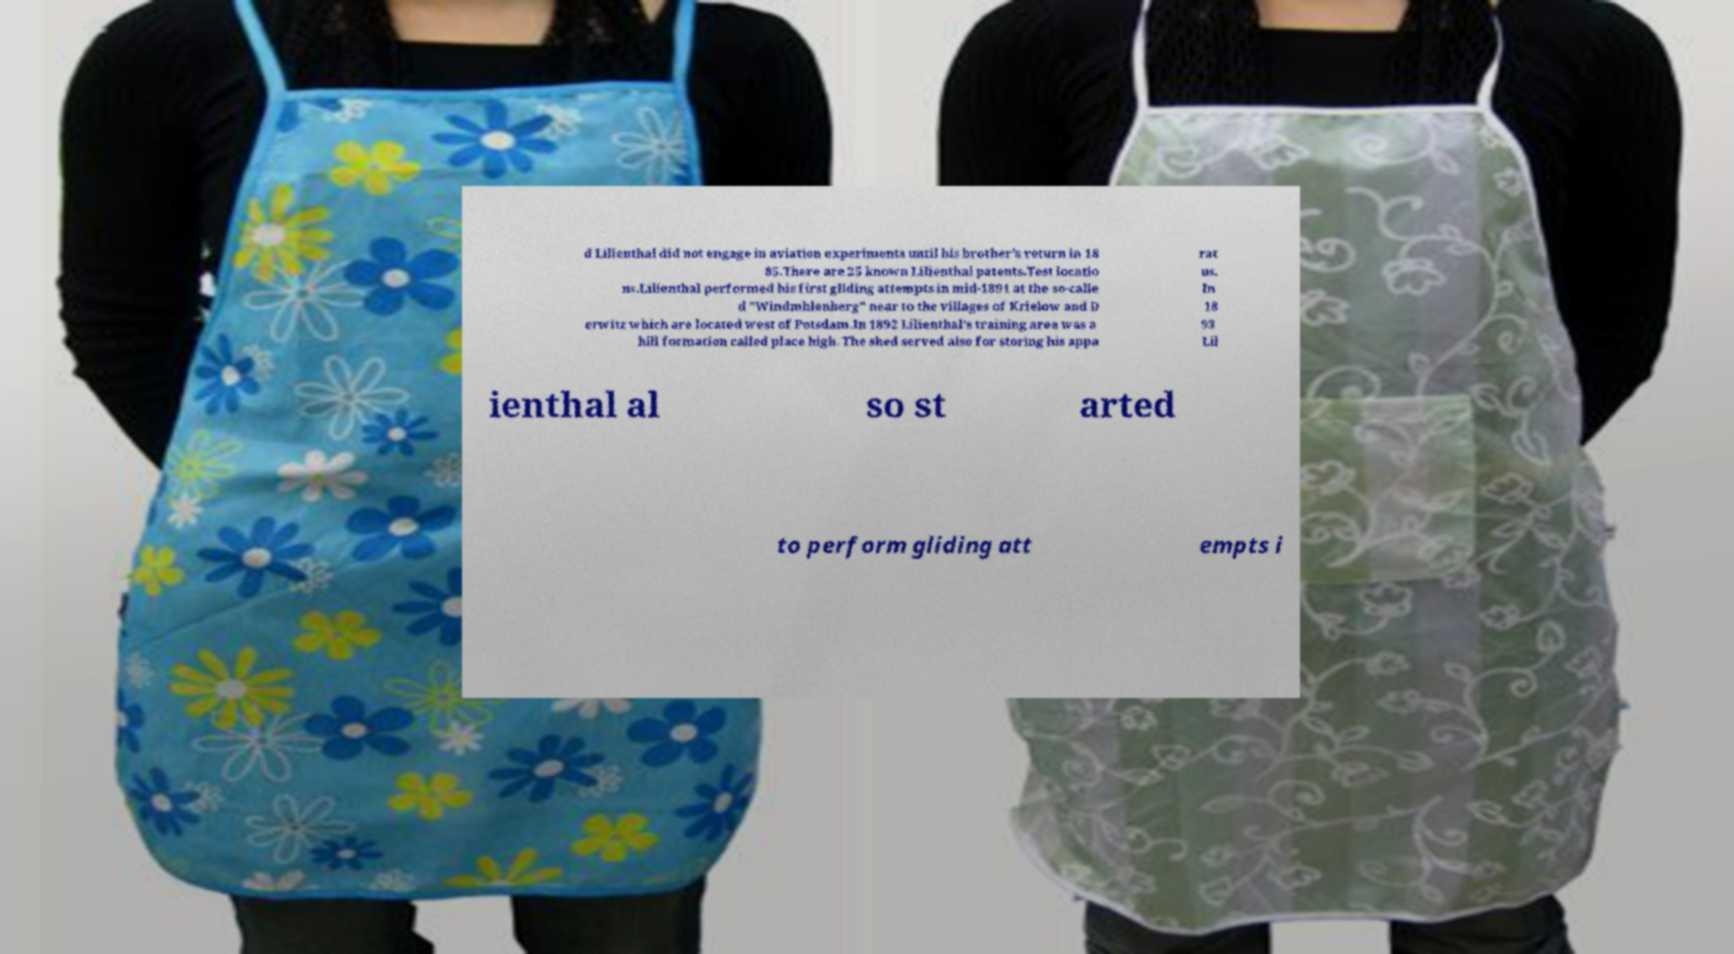Please read and relay the text visible in this image. What does it say? d Lilienthal did not engage in aviation experiments until his brother's return in 18 85.There are 25 known Lilienthal patents.Test locatio ns.Lilienthal performed his first gliding attempts in mid-1891 at the so-calle d "Windmhlenberg" near to the villages of Krielow and D erwitz which are located west of Potsdam.In 1892 Lilienthal's training area was a hill formation called place high. The shed served also for storing his appa rat us. In 18 93 Lil ienthal al so st arted to perform gliding att empts i 